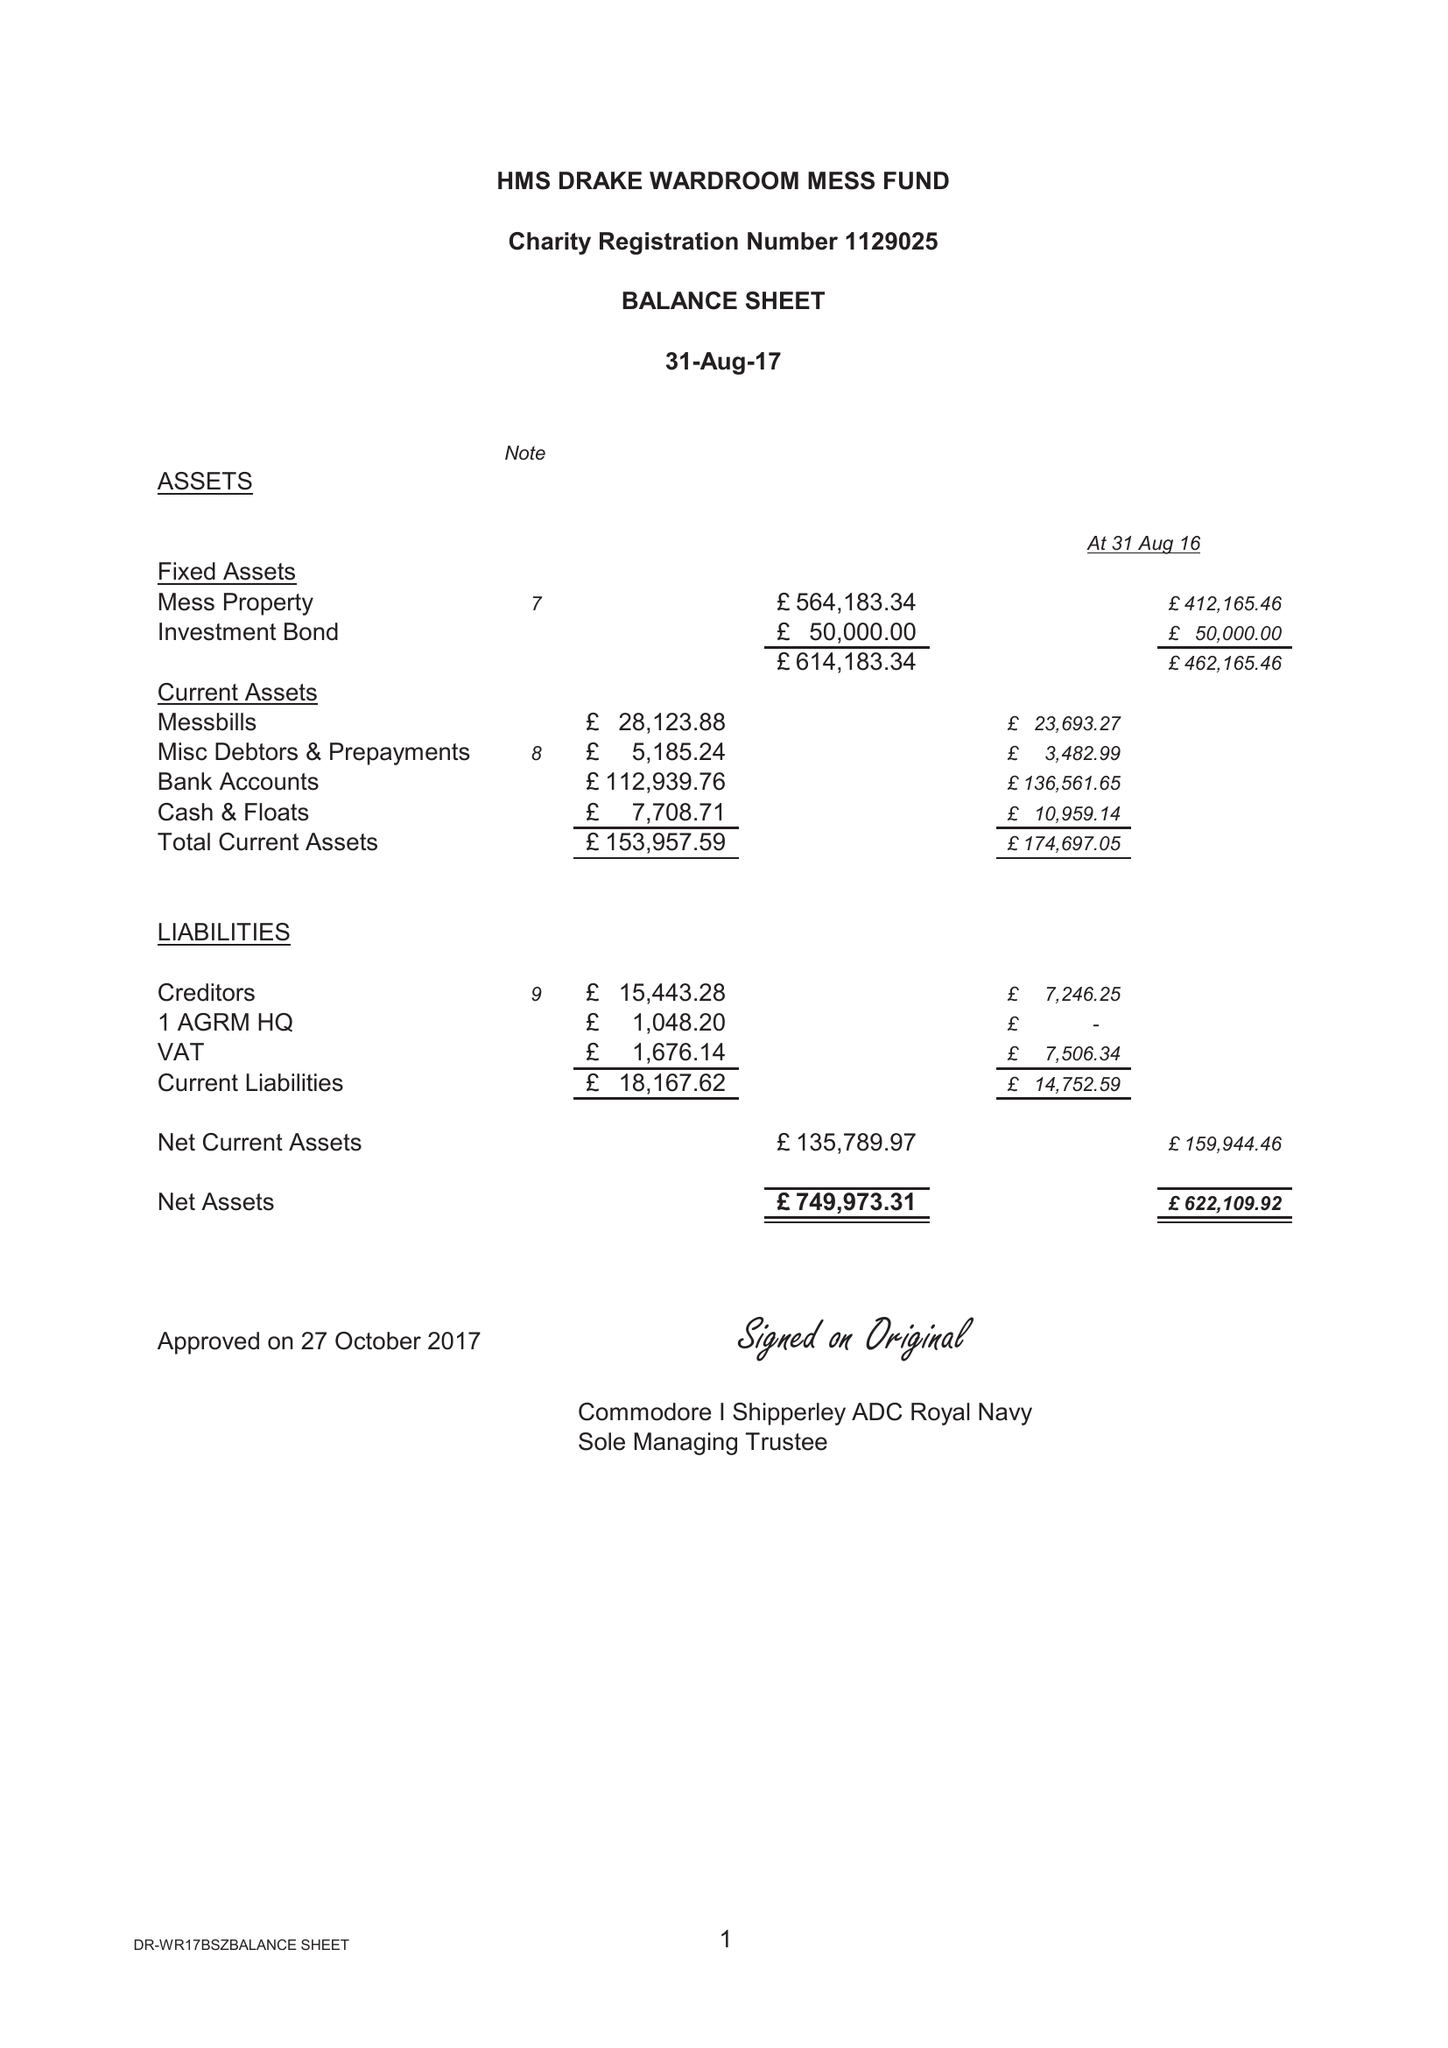What is the value for the income_annually_in_british_pounds?
Answer the question using a single word or phrase. 165389.99 